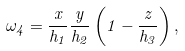Convert formula to latex. <formula><loc_0><loc_0><loc_500><loc_500>\omega _ { 4 } = \frac { x } { h _ { 1 } } \frac { y } { h _ { 2 } } \left ( 1 - \frac { z } { h _ { 3 } } \right ) ,</formula> 